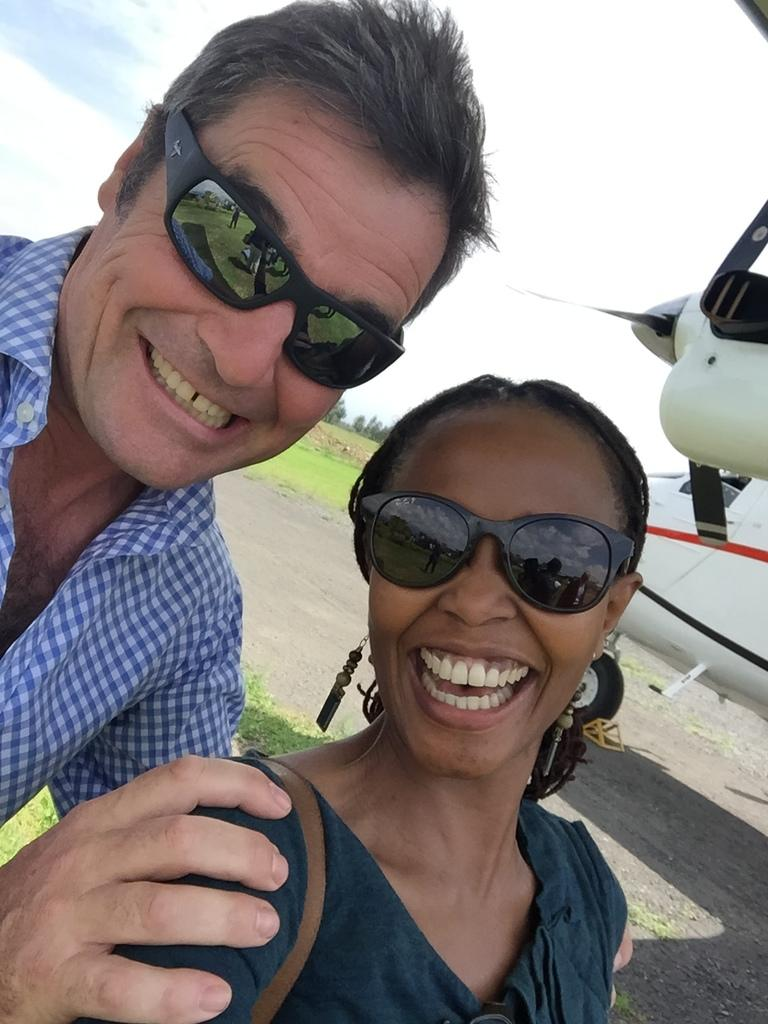How many people are in the image? There are two people in the image. What are the people wearing? The people are wearing goggles. What expression do the people have? The people are smiling. What can be seen in the background of the image? There is an airplane on the ground, grass, trees, and the sky visible in the background. What type of wealth is visible in the image? There is no visible wealth in the image; it features two people wearing goggles and smiling, with an airplane and natural elements in the background. Can you tell me how many toes the people have in the image? The image does not show the people's toes, so it cannot be determined from the picture. 